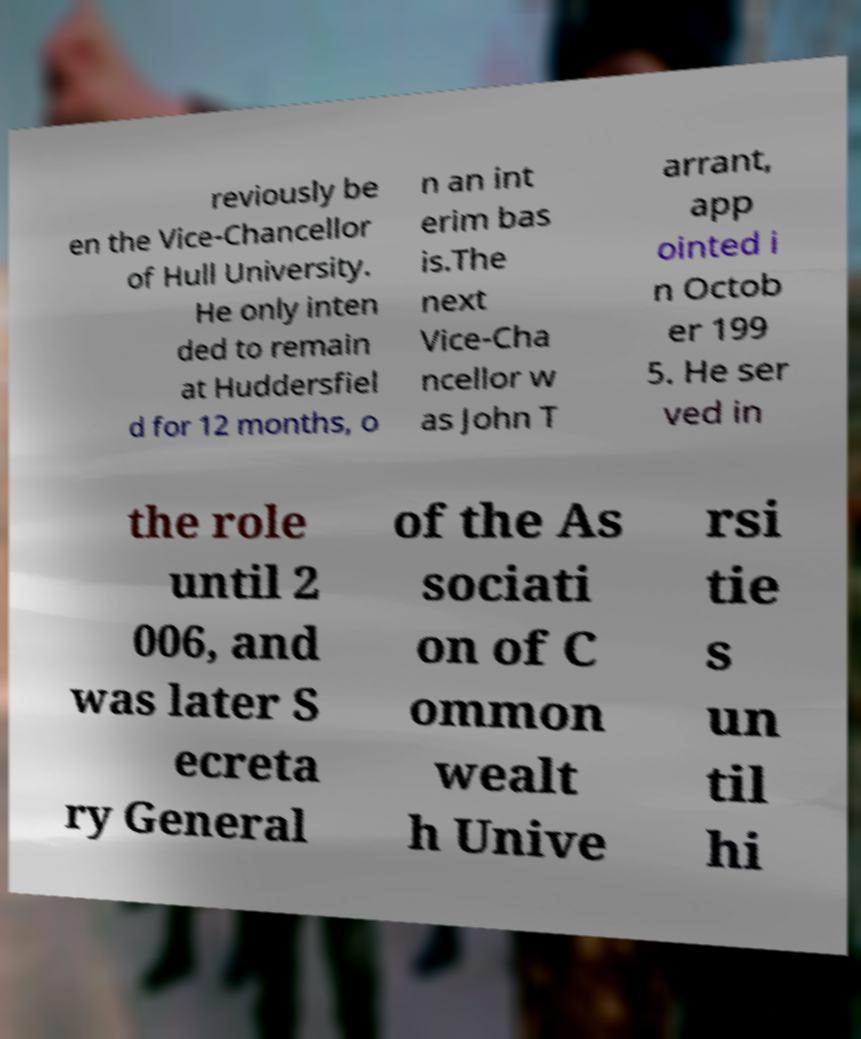Could you assist in decoding the text presented in this image and type it out clearly? reviously be en the Vice-Chancellor of Hull University. He only inten ded to remain at Huddersfiel d for 12 months, o n an int erim bas is.The next Vice-Cha ncellor w as John T arrant, app ointed i n Octob er 199 5. He ser ved in the role until 2 006, and was later S ecreta ry General of the As sociati on of C ommon wealt h Unive rsi tie s un til hi 